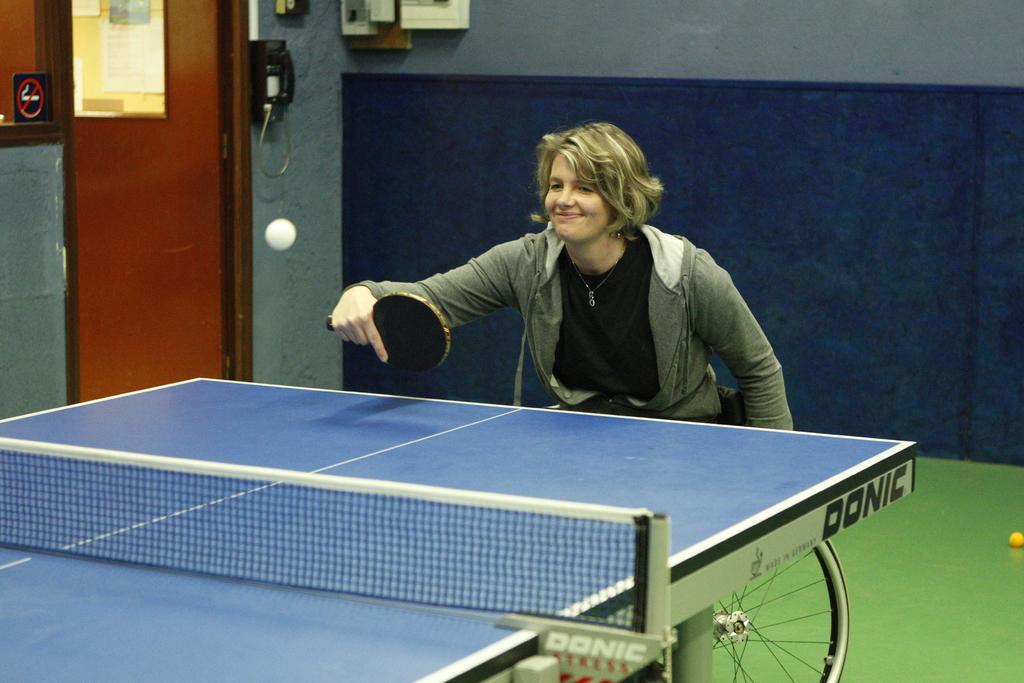Can you describe this image briefly? In this image a woman is playing table tennis by holding a bat in her hand and smiling. I can also see there is a table with a net on it. I can also see there is a door and a wall. 